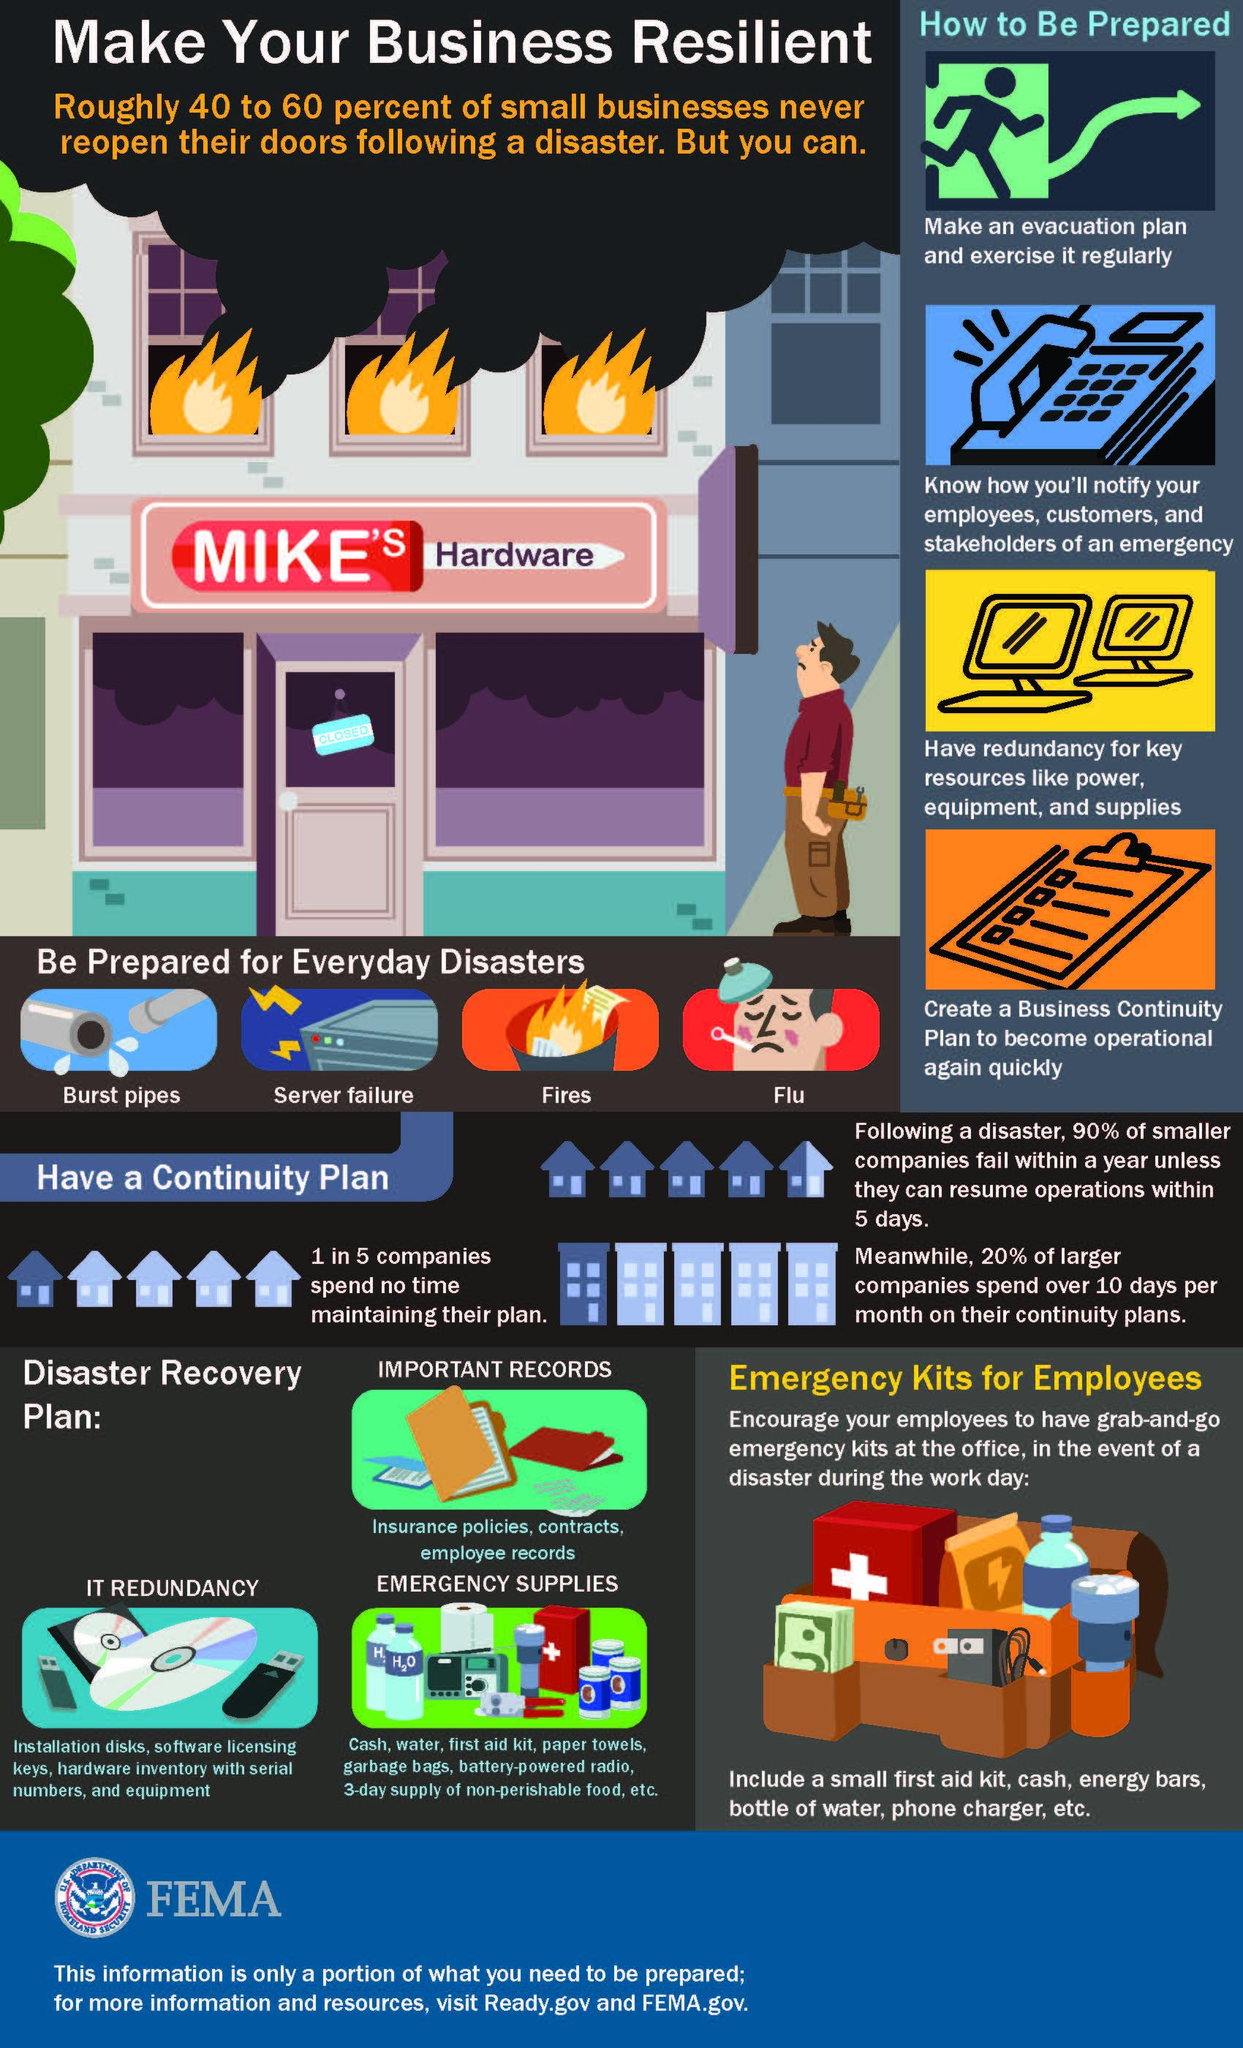Point out several critical features in this image. Mike's Hardware must prepare for the third type of disaster, which is fires. 